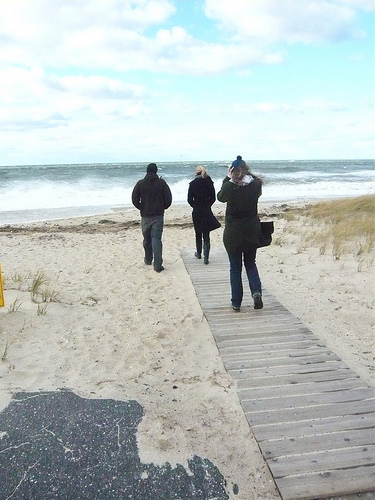<image>
Is there a sky behind the river? Yes. From this viewpoint, the sky is positioned behind the river, with the river partially or fully occluding the sky. 